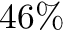Convert formula to latex. <formula><loc_0><loc_0><loc_500><loc_500>4 6 \%</formula> 